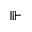Convert formula to latex. <formula><loc_0><loc_0><loc_500><loc_500>\ V v d a s h</formula> 